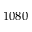Convert formula to latex. <formula><loc_0><loc_0><loc_500><loc_500>1 0 8 0</formula> 